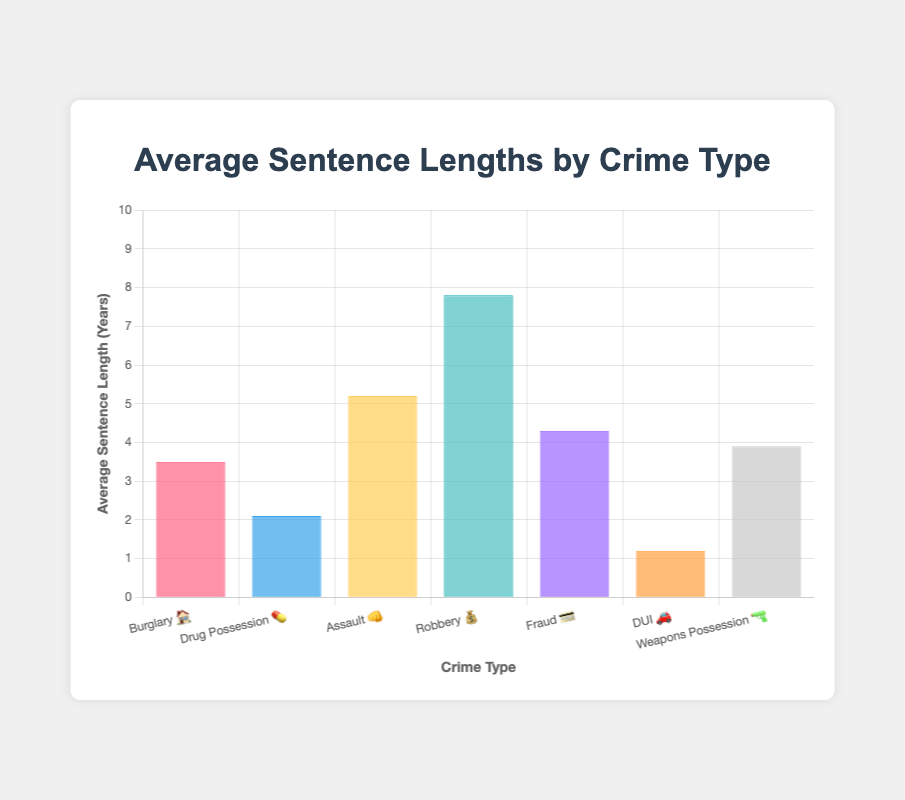Which crime has the longest average sentence? The crime with the longest average sentence is the one with the highest bar on the y-axis. By looking at the figure, 'Robbery 💰' has the highest average sentence length.
Answer: 'Robbery 💰' Which crime has the shortest average sentence? The crime with the shortest average sentence is the one with the lowest bar on the y-axis. 'DUI 🚗' has the lowest average sentence length.
Answer: 'DUI 🚗' What is the average sentence length for Assault? The average sentence length can be found directly on the y-axis corresponding to 'Assault 👊'. The value is 5.2 years.
Answer: 5.2 years How much longer is the average sentence for Robbery compared to Fraud? Subtract the average sentence length for Fraud from that of Robbery: 7.8 - 4.3.
Answer: 3.5 years What is the difference in average sentence lengths between Weapons Possession and DUI? Subtract the average sentence length for DUI from that of Weapons Possession: 3.9 - 1.2.
Answer: 2.7 years What is the combined average sentence length for Burglary and Assault? Add the average sentence lengths of Burglary (3.5) and Assault (5.2): 3.5 + 5.2.
Answer: 8.7 years What's the median average sentence length for the crimes listed? To find the median, list the sentences in ascending order: 1.2, 2.1, 3.5, 3.9, 4.3, 5.2, 7.8. The median is the middle value. In this list, it is 3.9.
Answer: 3.9 years Which crime has an average sentence length less than 3 years? By referring to the figure, identify the crimes with an average sentence length below 3 years. Both 'Drug Possession 💊' (2.1 years) and 'DUI 🚗' (1.2 years) meet this criterion.
Answer: 'Drug Possession 💊' and 'DUI 🚗' Is the average sentence for Assault more than twice that of DUI? Compare twice the average sentence of DUI (2 * 1.2 = 2.4) with the average sentence of Assault (5.2). 5.2 > 2.4 is true.
Answer: Yes 